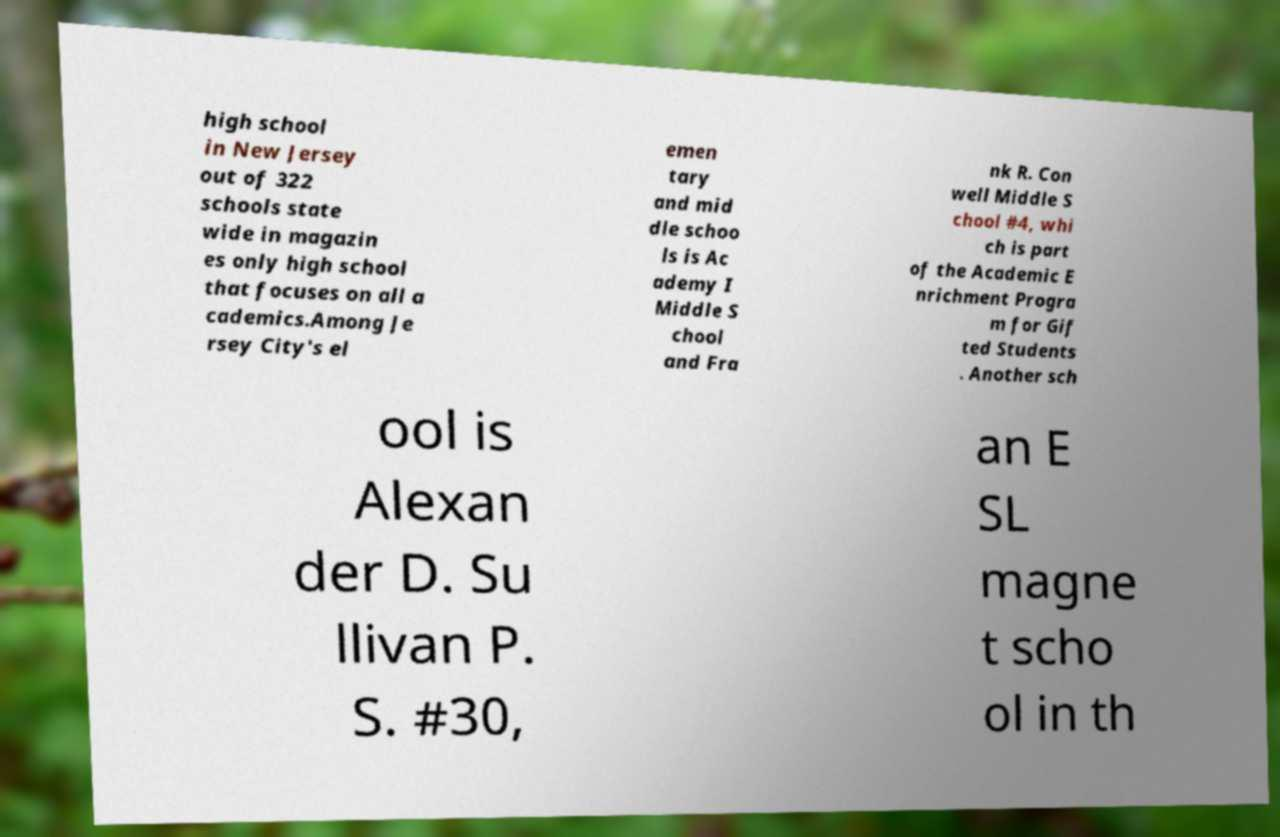For documentation purposes, I need the text within this image transcribed. Could you provide that? high school in New Jersey out of 322 schools state wide in magazin es only high school that focuses on all a cademics.Among Je rsey City's el emen tary and mid dle schoo ls is Ac ademy I Middle S chool and Fra nk R. Con well Middle S chool #4, whi ch is part of the Academic E nrichment Progra m for Gif ted Students . Another sch ool is Alexan der D. Su llivan P. S. #30, an E SL magne t scho ol in th 